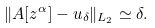Convert formula to latex. <formula><loc_0><loc_0><loc_500><loc_500>\| A [ z ^ { \alpha } ] - u _ { \delta } \| _ { L _ { 2 } } \simeq \delta .</formula> 